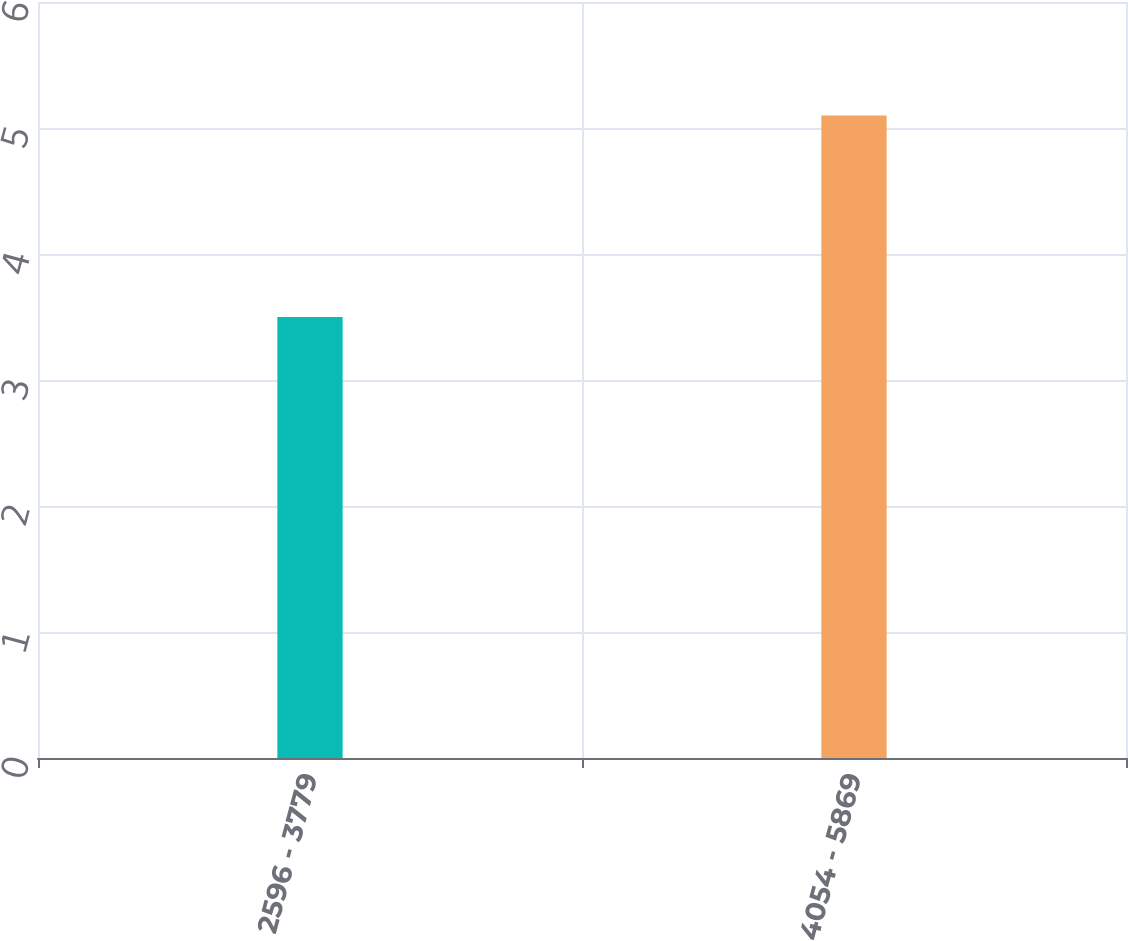Convert chart to OTSL. <chart><loc_0><loc_0><loc_500><loc_500><bar_chart><fcel>2596 - 3779<fcel>4054 - 5869<nl><fcel>3.5<fcel>5.1<nl></chart> 